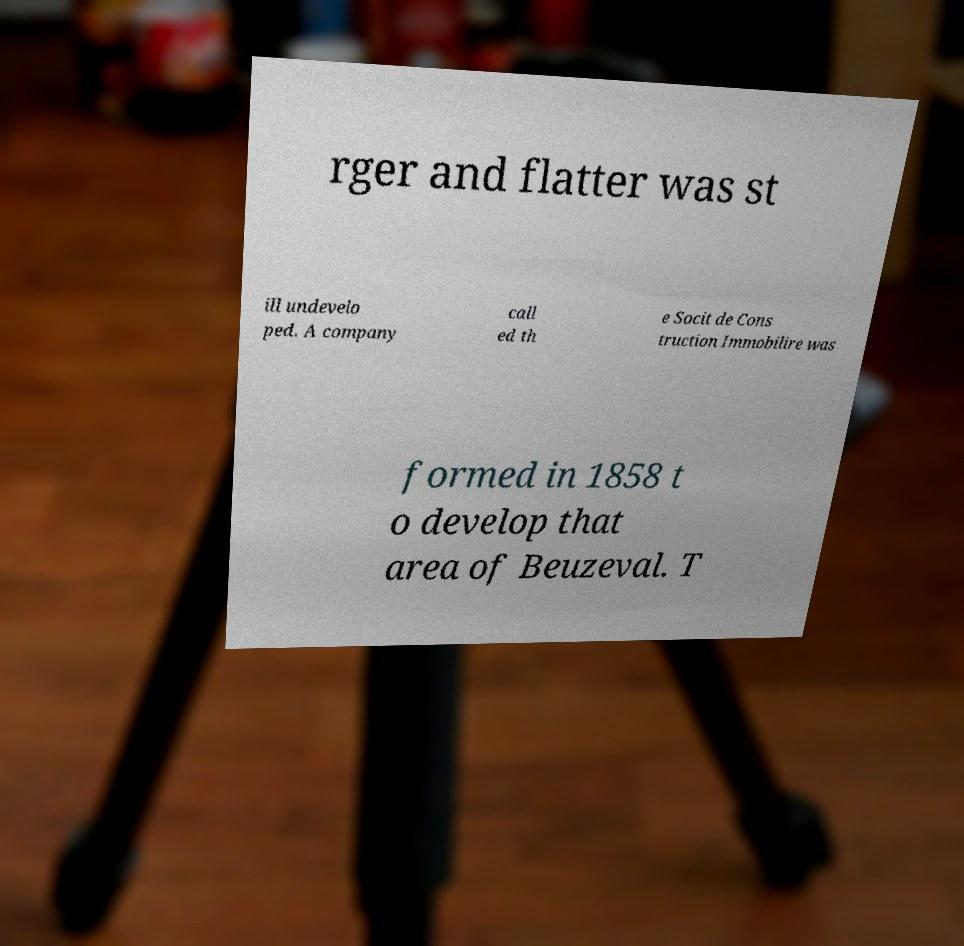Could you assist in decoding the text presented in this image and type it out clearly? rger and flatter was st ill undevelo ped. A company call ed th e Socit de Cons truction Immobilire was formed in 1858 t o develop that area of Beuzeval. T 